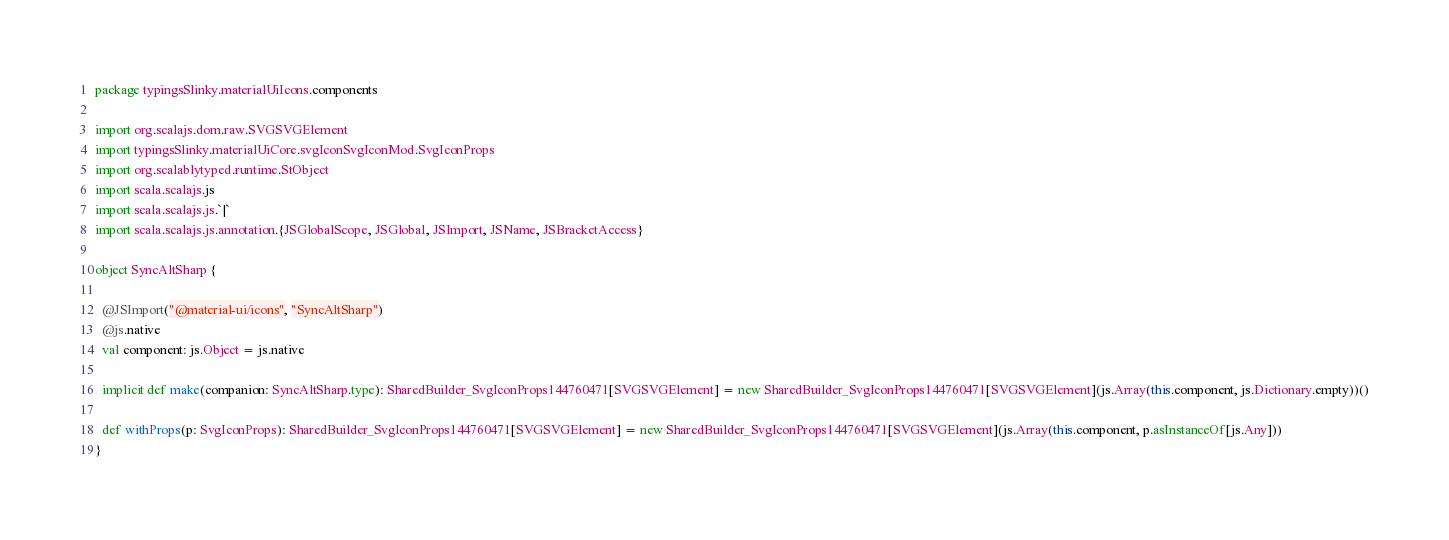<code> <loc_0><loc_0><loc_500><loc_500><_Scala_>package typingsSlinky.materialUiIcons.components

import org.scalajs.dom.raw.SVGSVGElement
import typingsSlinky.materialUiCore.svgIconSvgIconMod.SvgIconProps
import org.scalablytyped.runtime.StObject
import scala.scalajs.js
import scala.scalajs.js.`|`
import scala.scalajs.js.annotation.{JSGlobalScope, JSGlobal, JSImport, JSName, JSBracketAccess}

object SyncAltSharp {
  
  @JSImport("@material-ui/icons", "SyncAltSharp")
  @js.native
  val component: js.Object = js.native
  
  implicit def make(companion: SyncAltSharp.type): SharedBuilder_SvgIconProps144760471[SVGSVGElement] = new SharedBuilder_SvgIconProps144760471[SVGSVGElement](js.Array(this.component, js.Dictionary.empty))()
  
  def withProps(p: SvgIconProps): SharedBuilder_SvgIconProps144760471[SVGSVGElement] = new SharedBuilder_SvgIconProps144760471[SVGSVGElement](js.Array(this.component, p.asInstanceOf[js.Any]))
}
</code> 